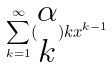Convert formula to latex. <formula><loc_0><loc_0><loc_500><loc_500>\sum _ { k = 1 } ^ { \infty } ( \begin{matrix} \alpha \\ k \end{matrix} ) k x ^ { k - 1 }</formula> 